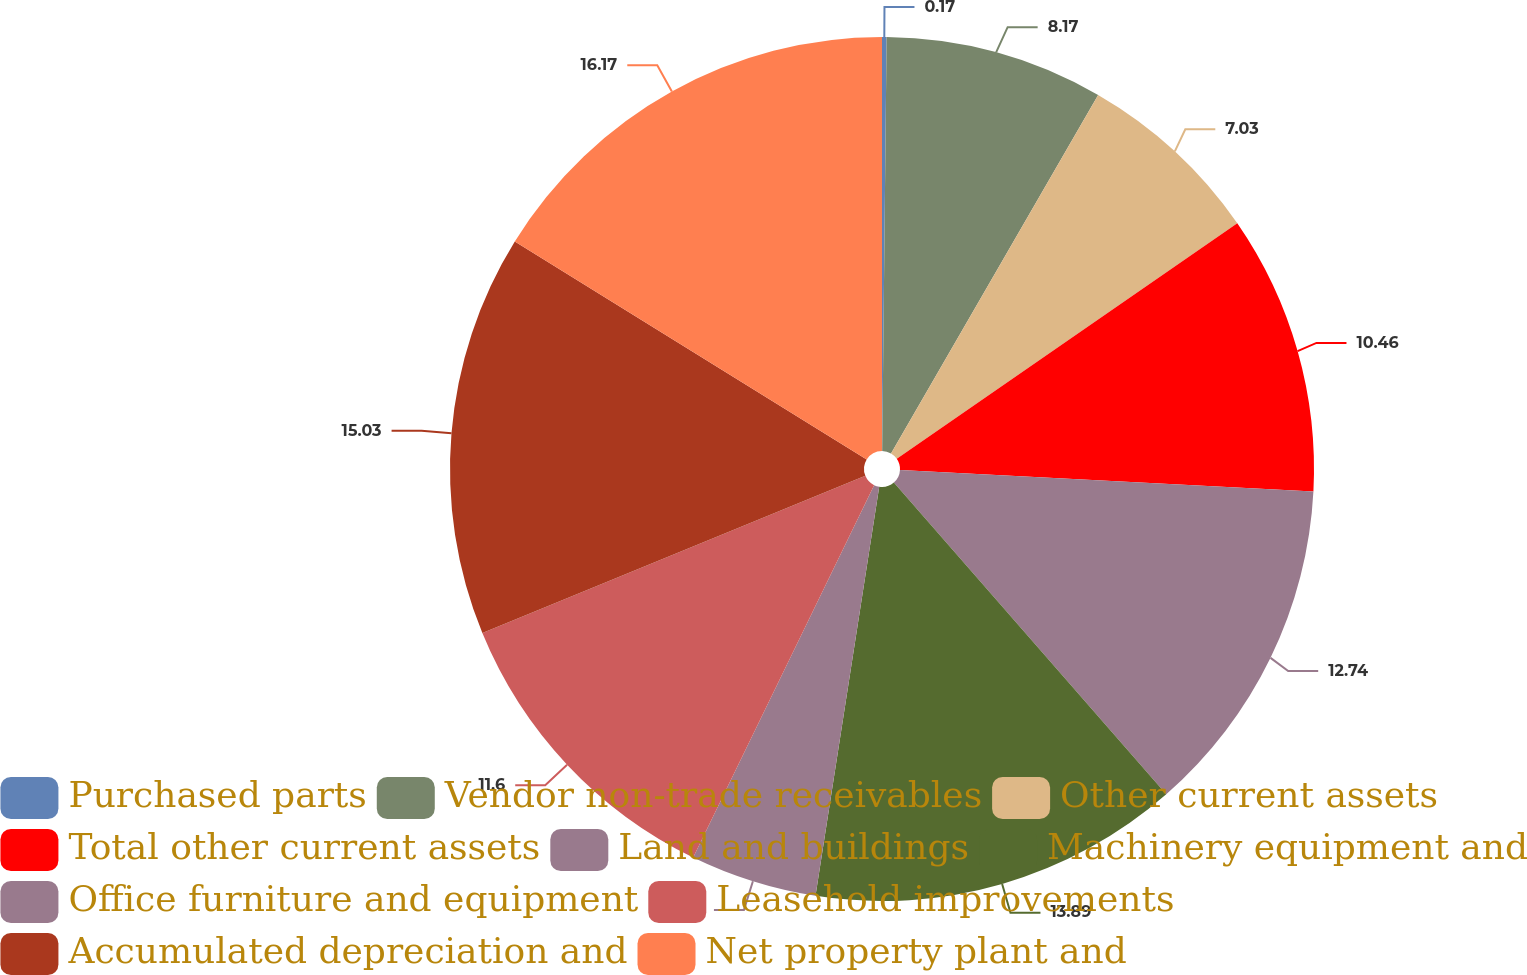Convert chart. <chart><loc_0><loc_0><loc_500><loc_500><pie_chart><fcel>Purchased parts<fcel>Vendor non-trade receivables<fcel>Other current assets<fcel>Total other current assets<fcel>Land and buildings<fcel>Machinery equipment and<fcel>Office furniture and equipment<fcel>Leasehold improvements<fcel>Accumulated depreciation and<fcel>Net property plant and<nl><fcel>0.17%<fcel>8.17%<fcel>7.03%<fcel>10.46%<fcel>12.74%<fcel>13.89%<fcel>4.74%<fcel>11.6%<fcel>15.03%<fcel>16.17%<nl></chart> 